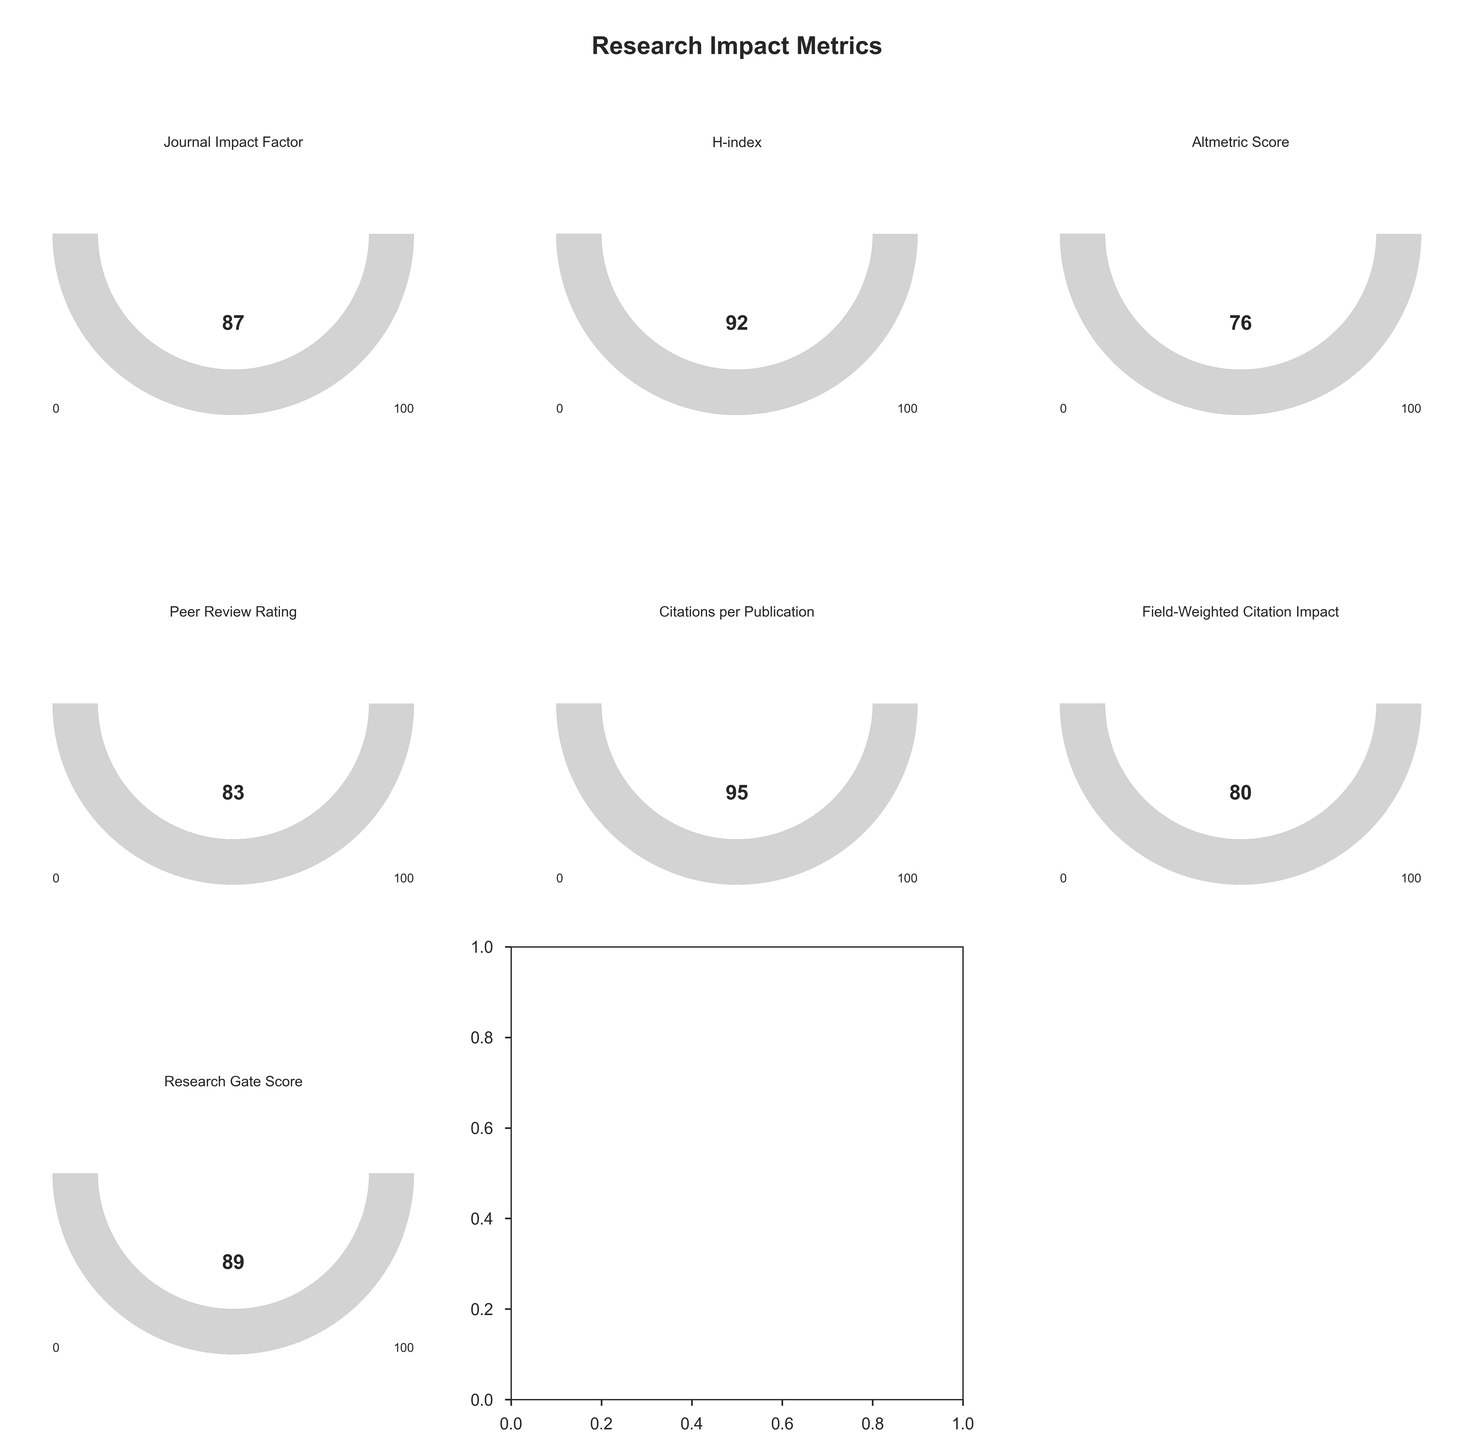What is the title of the figure? The title of the figure is prominently displayed at the top center of the figure. It reads "Research Impact Metrics".
Answer: Research Impact Metrics Which metric has the highest score? To determine this, look at each gauge chart and identify the score presented. The highest score is found in the metric "Citations per Publication" with a score of 95.
Answer: Citations per Publication What is the range of each gauge chart? Each gauge chart represents values from 0 to 100, as noted by the labels at the bottom of each chart (0 on the left and 100 on the right).
Answer: 0-100 What is the average score of all the metrics combined? Add all the scores together and divide by the number of metrics: (87 + 92 + 76 + 83 + 95 + 80 + 89) / 7 = 602 / 7 = 86.
Answer: 86 Which metric has the lowest score, and what is the score? Look at each gauge chart to identify the lowest score, which is 76 under the metric "Altmetric Score".
Answer: Altmetric Score, 76 How many metrics have scores above 90? Count the number of metrics that have scores greater than 90. They are "H-index" with 92 and "Citations per Publication" with 95. Thus, there are 2 metrics.
Answer: 2 How does the Peer Review Rating compare to the Journal Impact Factor? The Peer Review Rating score is 83, and the Journal Impact Factor score is 87. Thus, the Peer Review Rating is 4 points lower than the Journal Impact Factor.
Answer: 4 points lower Which metric is shown in the middle bottom of the figure? The middle bottom position on the grid corresponds to the second metric in the last row, which is "Research Gate Score".
Answer: Research Gate Score What's the difference between the highest and the lowest score among all metrics? The highest score is 95 (Citations per Publication), and the lowest is 76 (Altmetric Score). The difference is 95 - 76 = 19.
Answer: 19 